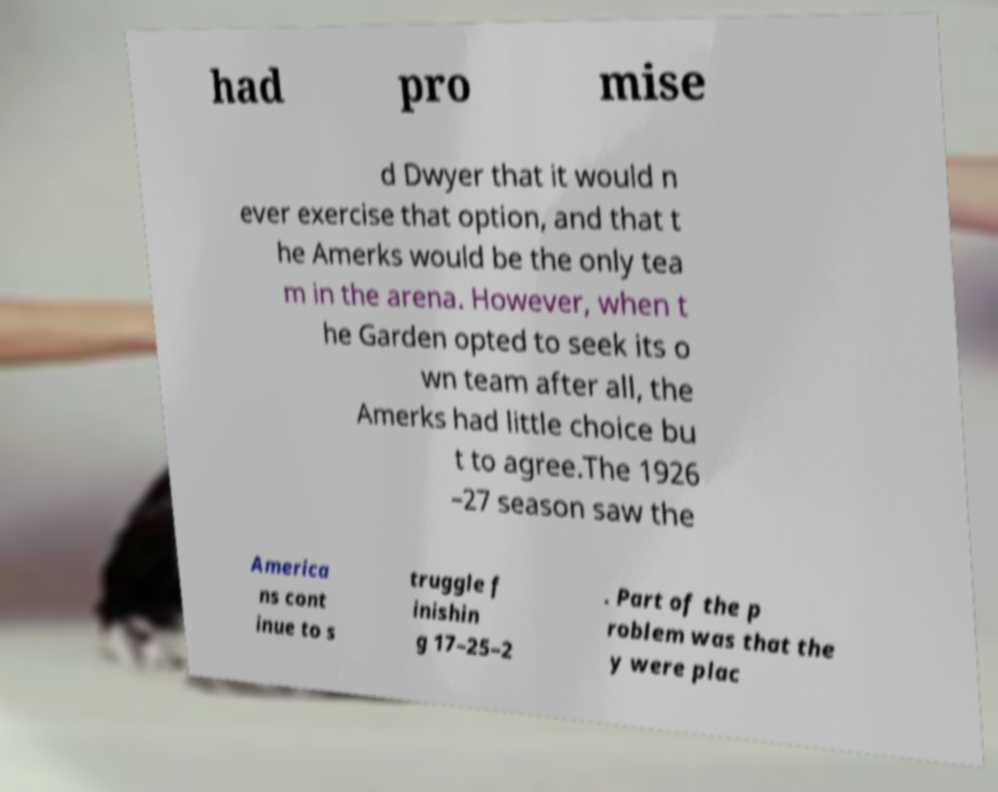What messages or text are displayed in this image? I need them in a readable, typed format. had pro mise d Dwyer that it would n ever exercise that option, and that t he Amerks would be the only tea m in the arena. However, when t he Garden opted to seek its o wn team after all, the Amerks had little choice bu t to agree.The 1926 –27 season saw the America ns cont inue to s truggle f inishin g 17–25–2 . Part of the p roblem was that the y were plac 